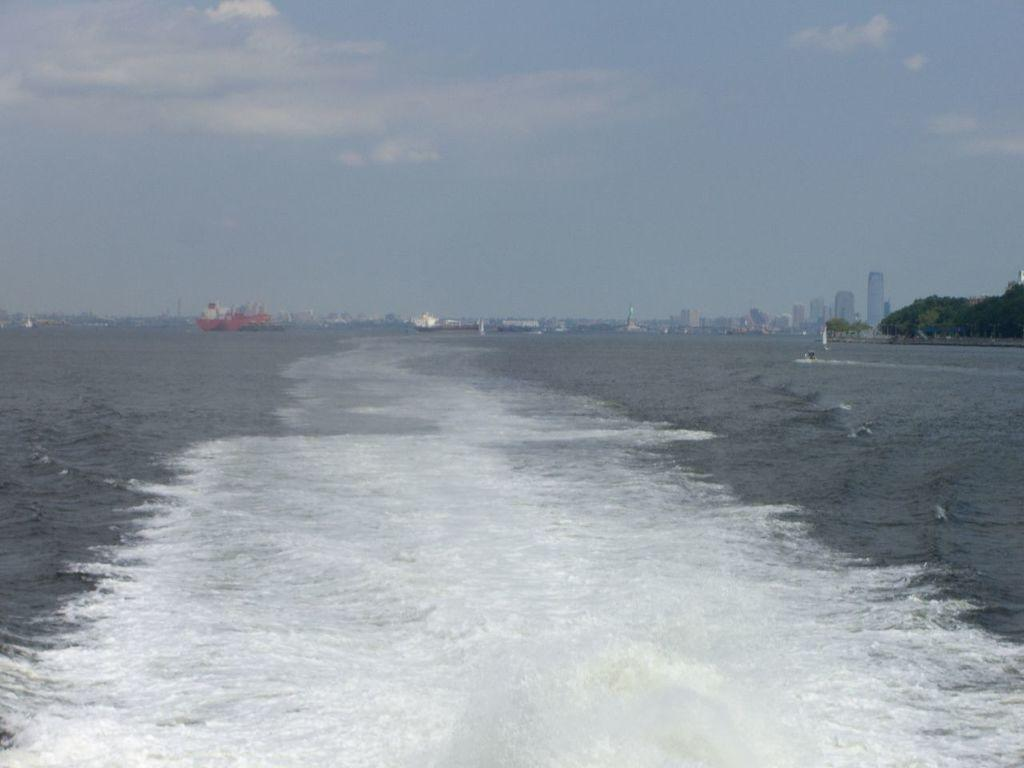What is visible at the top of the image? The sky is visible at the top of the image. What can be seen in the sky? There are clouds in the sky. What type of structures are present in the image? There are buildings in the image. What type of vegetation is on the right side of the image? There are trees towards the right side of the image. What natural feature is present in the image? The sea is present in the image. How many trees are in the flock depicted in the image? There is no flock of trees or any other animals present in the image; it features buildings, trees, and the sea. What type of memory is stored in the image? The image does not contain any memory or storage devices; it is a visual representation of a scene. 